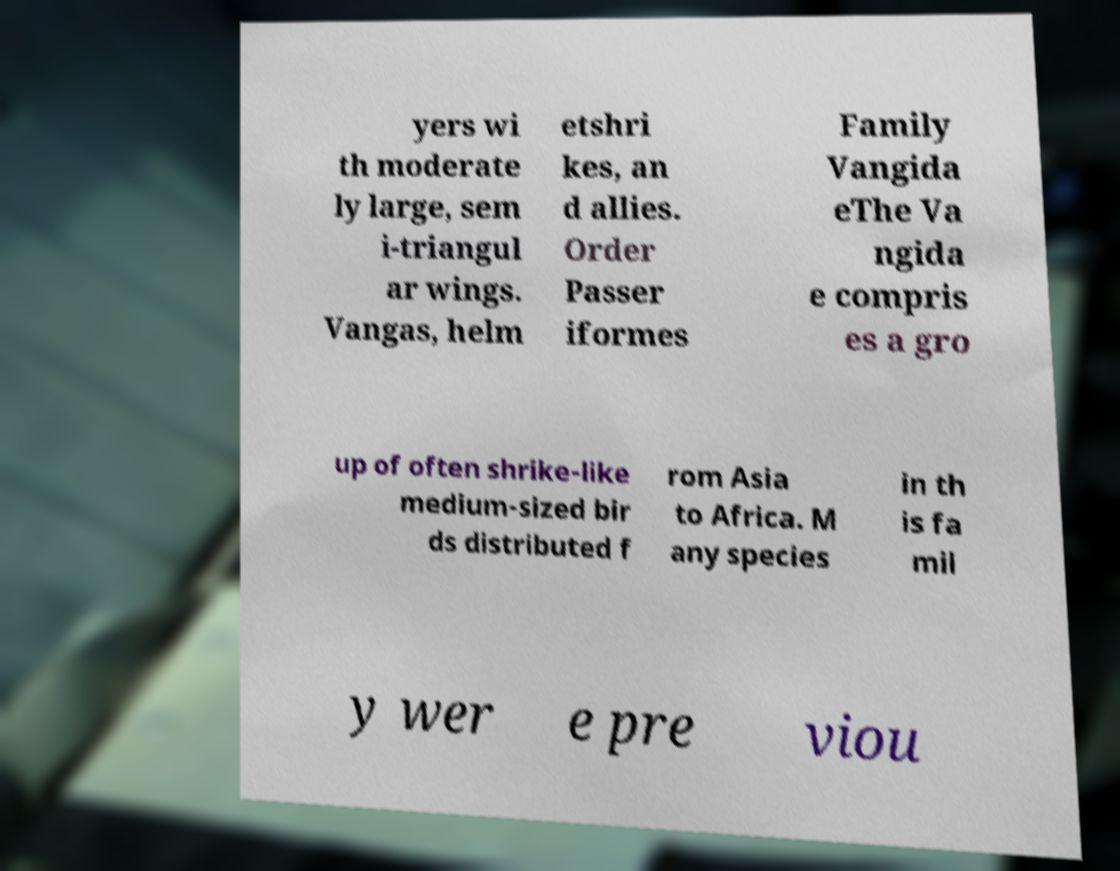Could you extract and type out the text from this image? yers wi th moderate ly large, sem i-triangul ar wings. Vangas, helm etshri kes, an d allies. Order Passer iformes Family Vangida eThe Va ngida e compris es a gro up of often shrike-like medium-sized bir ds distributed f rom Asia to Africa. M any species in th is fa mil y wer e pre viou 